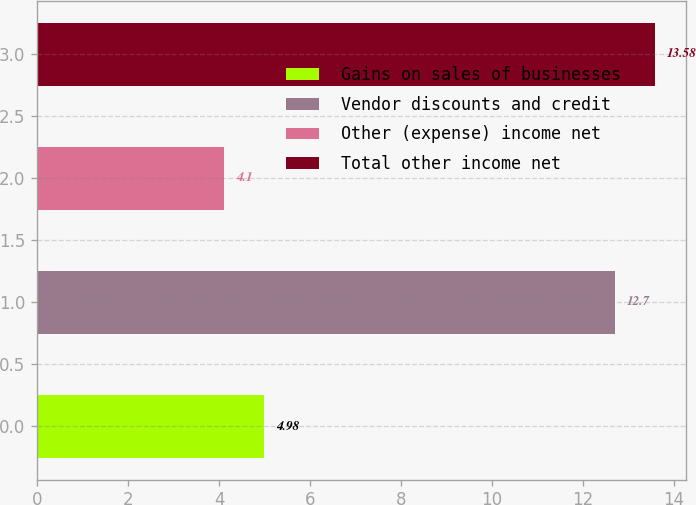Convert chart. <chart><loc_0><loc_0><loc_500><loc_500><bar_chart><fcel>Gains on sales of businesses<fcel>Vendor discounts and credit<fcel>Other (expense) income net<fcel>Total other income net<nl><fcel>4.98<fcel>12.7<fcel>4.1<fcel>13.58<nl></chart> 